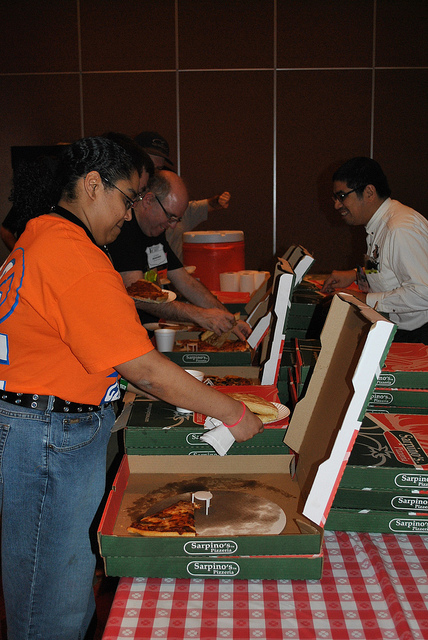<image>What can you do with that design on the table? It is ambiguous what you can do with that design on the table. It can be used for decoration, playing checkers, making clothing or covering the table. What can you do with that design on the table? I don't know what can be done with that design on the table. It can be used for decoration or to make clothing. 